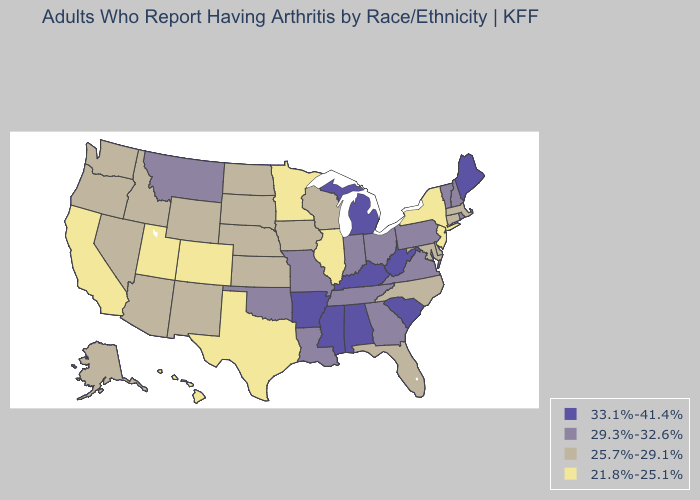Name the states that have a value in the range 33.1%-41.4%?
Quick response, please. Alabama, Arkansas, Kentucky, Maine, Michigan, Mississippi, South Carolina, West Virginia. Which states have the highest value in the USA?
Write a very short answer. Alabama, Arkansas, Kentucky, Maine, Michigan, Mississippi, South Carolina, West Virginia. Name the states that have a value in the range 25.7%-29.1%?
Write a very short answer. Alaska, Arizona, Connecticut, Delaware, Florida, Idaho, Iowa, Kansas, Maryland, Massachusetts, Nebraska, Nevada, New Mexico, North Carolina, North Dakota, Oregon, South Dakota, Washington, Wisconsin, Wyoming. What is the highest value in the West ?
Keep it brief. 29.3%-32.6%. Does North Carolina have a higher value than Pennsylvania?
Be succinct. No. Name the states that have a value in the range 21.8%-25.1%?
Concise answer only. California, Colorado, Hawaii, Illinois, Minnesota, New Jersey, New York, Texas, Utah. Name the states that have a value in the range 25.7%-29.1%?
Concise answer only. Alaska, Arizona, Connecticut, Delaware, Florida, Idaho, Iowa, Kansas, Maryland, Massachusetts, Nebraska, Nevada, New Mexico, North Carolina, North Dakota, Oregon, South Dakota, Washington, Wisconsin, Wyoming. What is the value of Kansas?
Quick response, please. 25.7%-29.1%. Does Nevada have the lowest value in the USA?
Write a very short answer. No. Name the states that have a value in the range 29.3%-32.6%?
Give a very brief answer. Georgia, Indiana, Louisiana, Missouri, Montana, New Hampshire, Ohio, Oklahoma, Pennsylvania, Rhode Island, Tennessee, Vermont, Virginia. How many symbols are there in the legend?
Quick response, please. 4. Does Washington have a higher value than Hawaii?
Concise answer only. Yes. Does Delaware have the same value as Wisconsin?
Short answer required. Yes. Does Michigan have the highest value in the MidWest?
Answer briefly. Yes. What is the highest value in the USA?
Answer briefly. 33.1%-41.4%. 